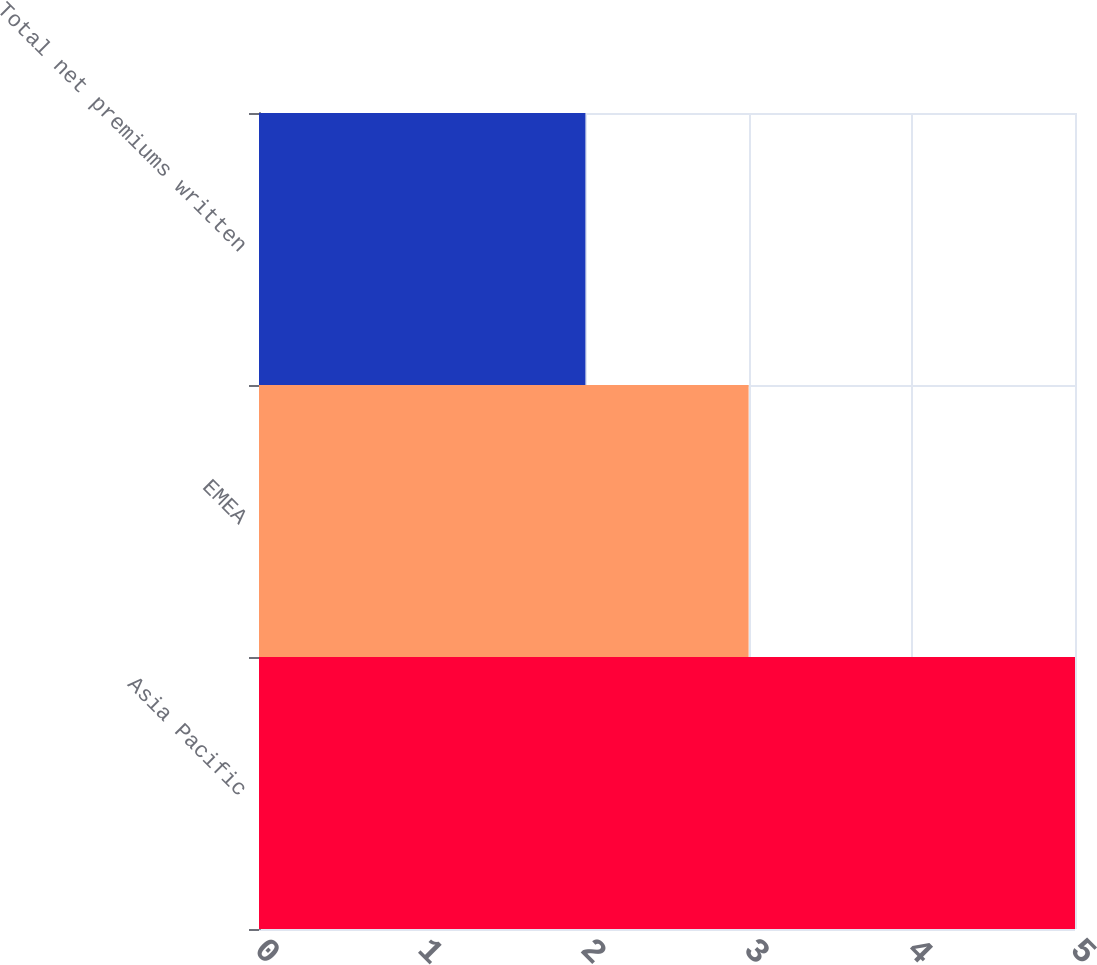<chart> <loc_0><loc_0><loc_500><loc_500><bar_chart><fcel>Asia Pacific<fcel>EMEA<fcel>Total net premiums written<nl><fcel>5<fcel>3<fcel>2<nl></chart> 